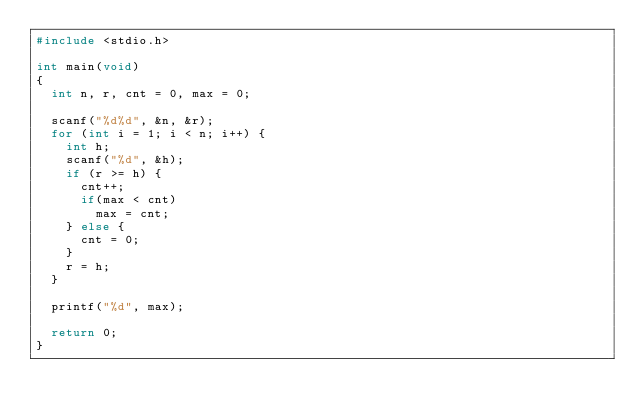Convert code to text. <code><loc_0><loc_0><loc_500><loc_500><_C_>#include <stdio.h>

int main(void)
{
  int n, r, cnt = 0, max = 0;
  
  scanf("%d%d", &n, &r);
  for (int i = 1; i < n; i++) {
    int h;
    scanf("%d", &h);
    if (r >= h) {
      cnt++;
      if(max < cnt)
        max = cnt;
    } else {
      cnt = 0;
    }
    r = h;
  }
  
  printf("%d", max);
  
  return 0;
}</code> 